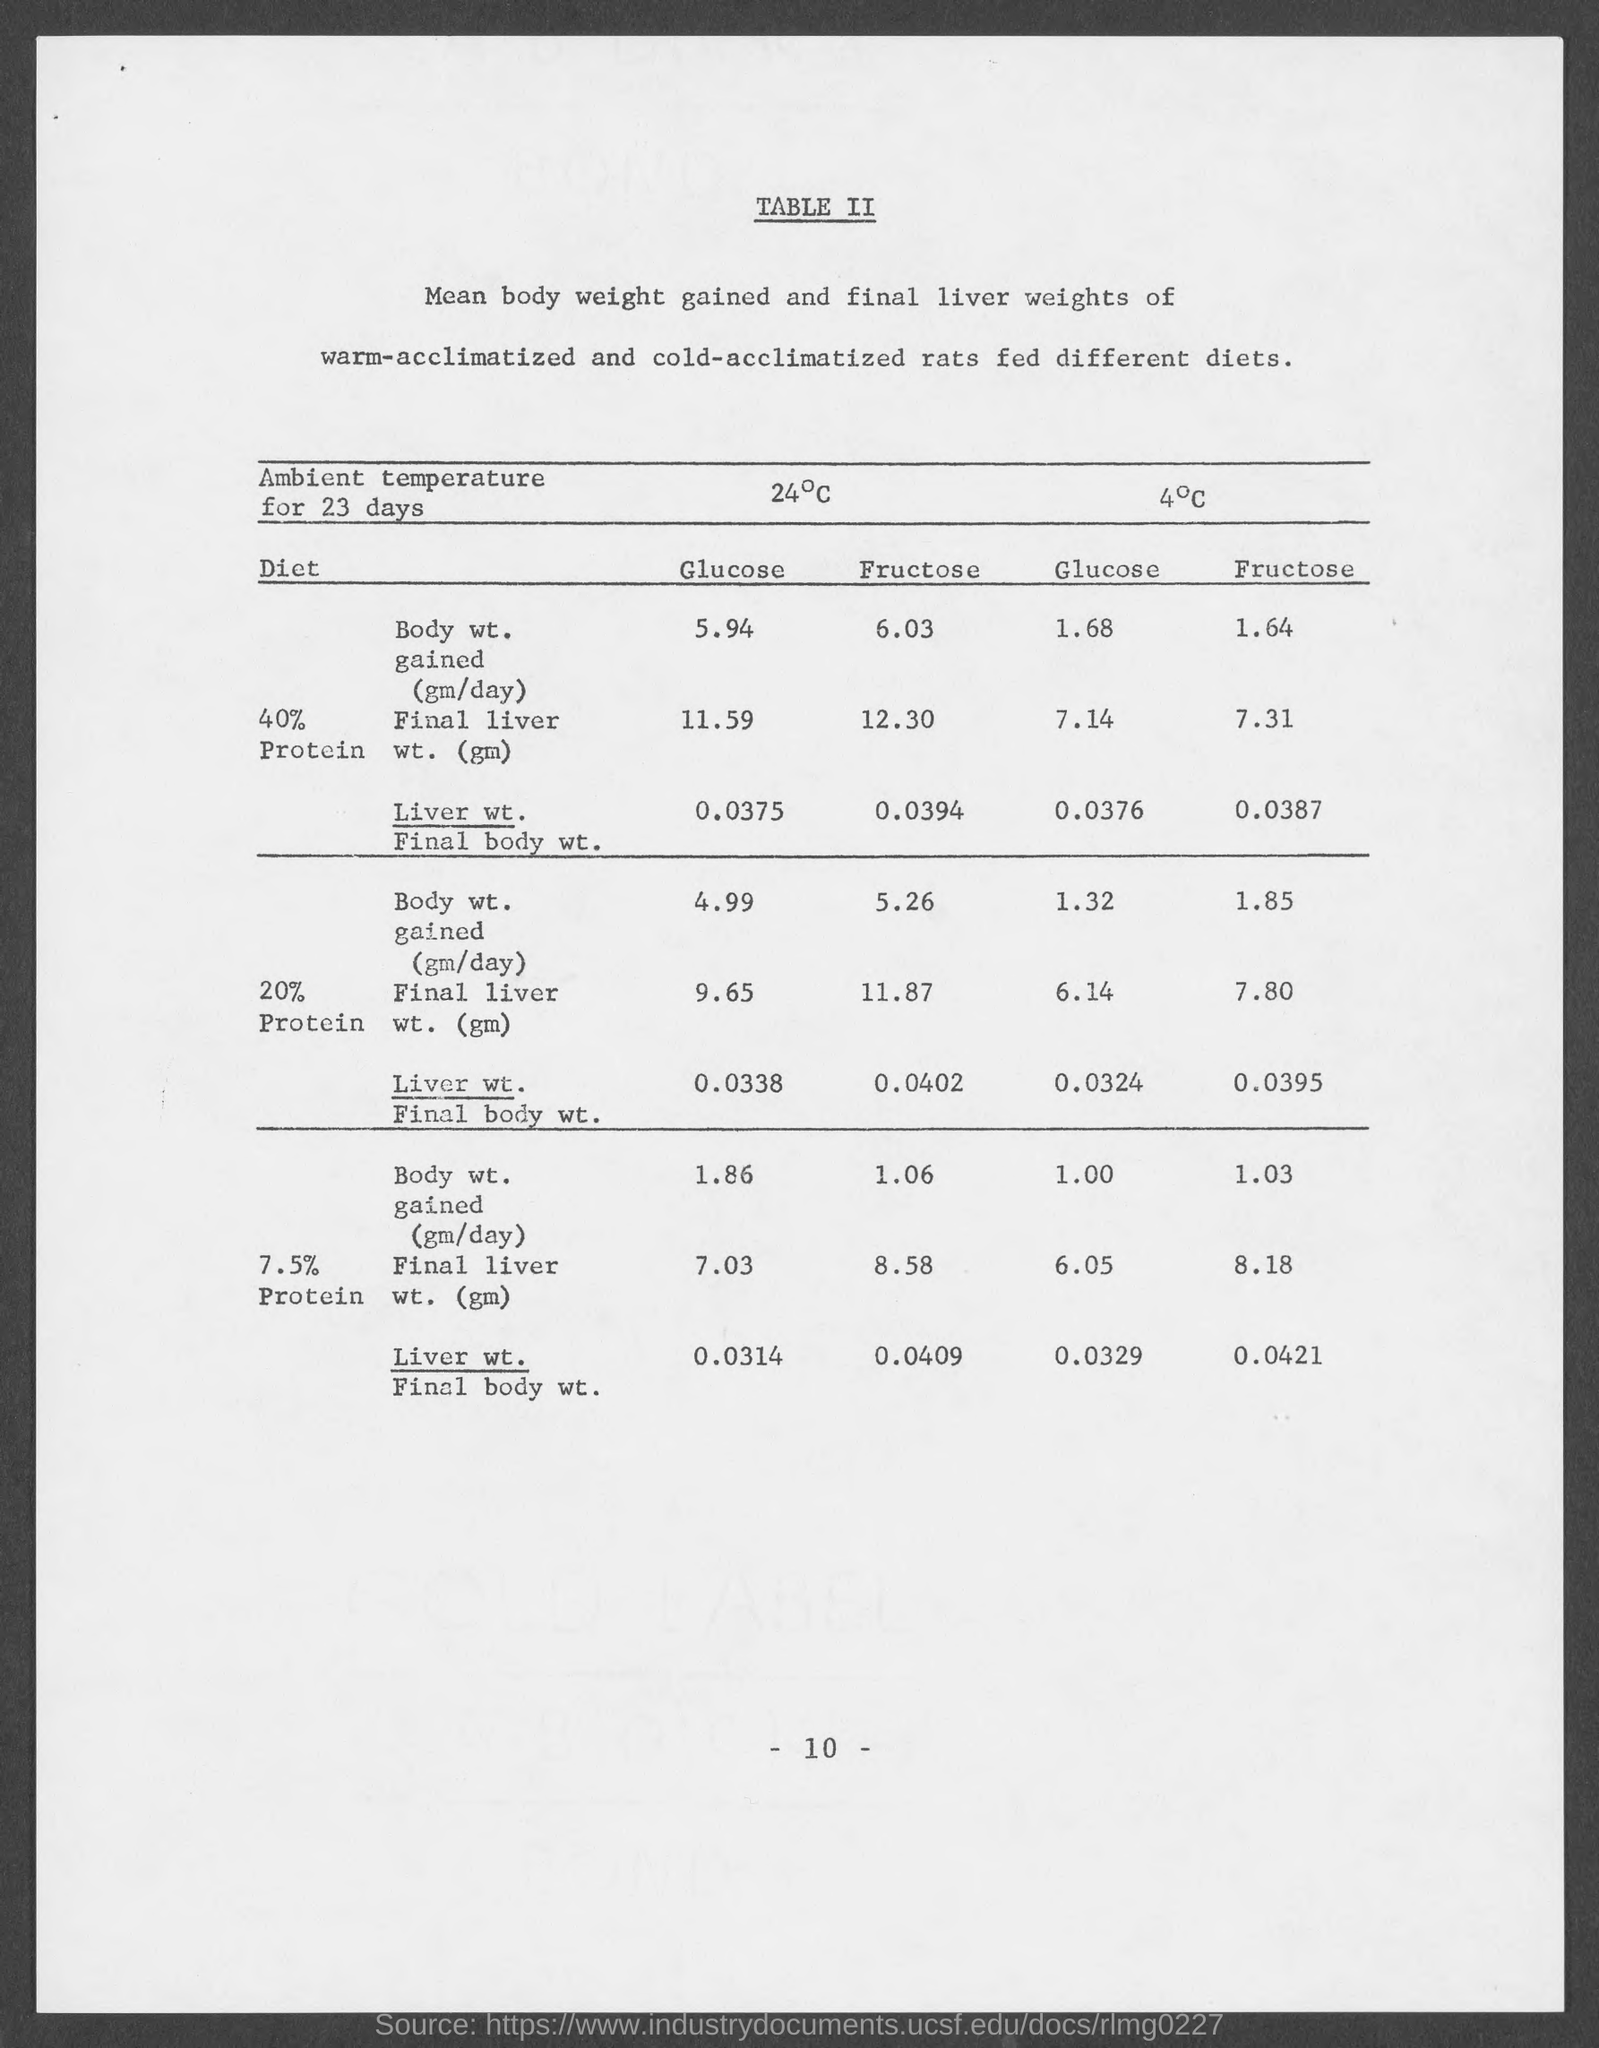What is the page number at bottom of the page?
Offer a terse response. - 10 -. 